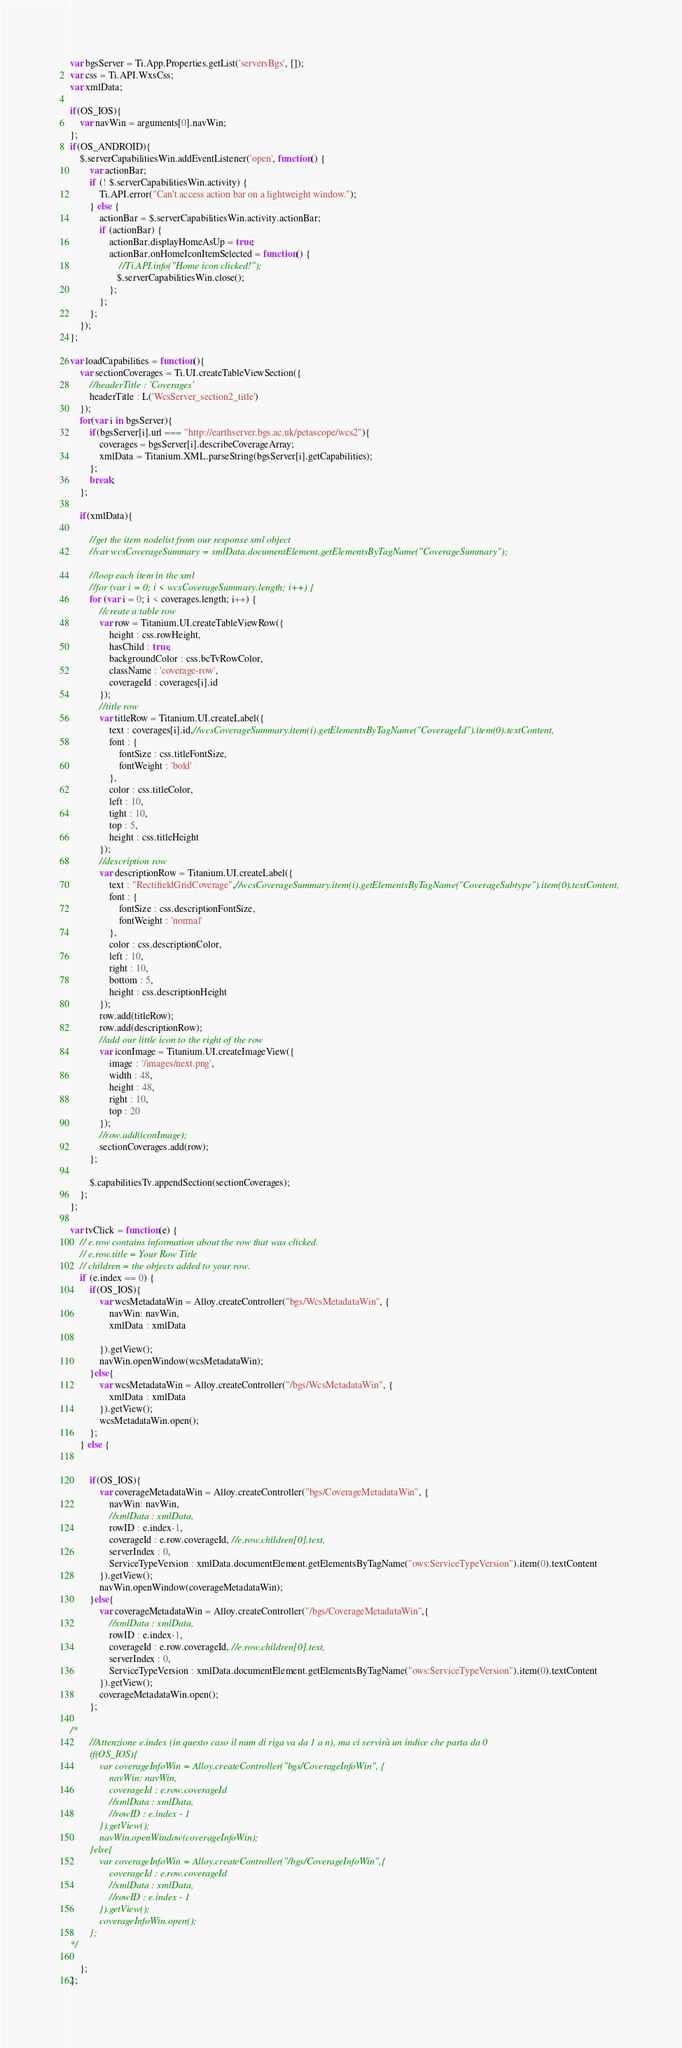Convert code to text. <code><loc_0><loc_0><loc_500><loc_500><_JavaScript_>var bgsServer = Ti.App.Properties.getList('serversBgs', []);
var css = Ti.API.WxsCss;
var xmlData;

if(OS_IOS){
	var navWin = arguments[0].navWin;
};
if(OS_ANDROID){
	$.serverCapabilitiesWin.addEventListener('open', function() {
		var actionBar;	
	    if (! $.serverCapabilitiesWin.activity) {
	        Ti.API.error("Can't access action bar on a lightweight window.");
	    } else {
	        actionBar = $.serverCapabilitiesWin.activity.actionBar;
	        if (actionBar) {
	            actionBar.displayHomeAsUp = true;
	            actionBar.onHomeIconItemSelected = function() {
	                //Ti.API.info("Home icon clicked!");
	               $.serverCapabilitiesWin.close();
	            };
	        };	        
	    };
	});	
};

var loadCapabilities = function(){
	var sectionCoverages = Ti.UI.createTableViewSection({
		//headerTitle : 'Coverages'
		headerTitle : L('WcsServer_section2_title')
	});	
	for(var i in bgsServer){
		if(bgsServer[i].url === "http://earthserver.bgs.ac.uk/petascope/wcs2"){
			coverages = bgsServer[i].describeCoverageArray;
			xmlData = Titanium.XML.parseString(bgsServer[i].getCapabilities);
		};
		break;
	};

	if(xmlData){
		
		//get the item nodelist from our response xml object
		//var wcsCoverageSummary = xmlData.documentElement.getElementsByTagName("CoverageSummary");
		
		//loop each item in the xml
		//for (var i = 0; i < wcsCoverageSummary.length; i++) {
		for (var i = 0; i < coverages.length; i++) {	
			//create a table row
			var row = Titanium.UI.createTableViewRow({
				height : css.rowHeight,
				hasChild : true,
				backgroundColor : css.bcTvRowColor,
				className : 'coverage-row',
				coverageId : coverages[i].id
			});
			//title row
			var titleRow = Titanium.UI.createLabel({
				text : coverages[i].id,//wcsCoverageSummary.item(i).getElementsByTagName("CoverageId").item(0).textContent,
				font : {
					fontSize : css.titleFontSize,
					fontWeight : 'bold'
				},
				color : css.titleColor,
				left : 10,
				tight : 10,
				top : 5,
				height : css.titleHeight
			});
			//description row
			var descriptionRow = Titanium.UI.createLabel({
				text : "RectifieldGridCoverage",//wcsCoverageSummary.item(i).getElementsByTagName("CoverageSubtype").item(0).textContent,
				font : {
					fontSize : css.descriptionFontSize,
					fontWeight : 'normal'
				},
				color : css.descriptionColor,
				left : 10,
				right : 10,
				bottom : 5,
				height : css.descriptionHeight
			});
			row.add(titleRow);
			row.add(descriptionRow);
			//add our little icon to the right of the row
			var iconImage = Titanium.UI.createImageView({
				image : '/images/next.png',
				width : 48,
				height : 48,
				right : 10,
				top : 20
			});
			//row.add(iconImage);
			sectionCoverages.add(row);
		};
		
		$.capabilitiesTv.appendSection(sectionCoverages);
	};
};

var tvClick = function(e) {
	// e.row contains information about the row that was clicked.
	// e.row.title = Your Row Title
	// children = the objects added to your row.
	if (e.index == 0) {
		if(OS_IOS){
			var wcsMetadataWin = Alloy.createController("bgs/WcsMetadataWin", {
				navWin: navWin,
				xmlData : xmlData
				
			}).getView();
			navWin.openWindow(wcsMetadataWin);
		}else{
			var wcsMetadataWin = Alloy.createController("/bgs/WcsMetadataWin", {
				xmlData : xmlData
			}).getView();
			wcsMetadataWin.open();
		};		
	} else {

	
		if(OS_IOS){
			var coverageMetadataWin = Alloy.createController("bgs/CoverageMetadataWin", {
				navWin: navWin,
				//xmlData : xmlData,
				rowID : e.index-1,
				coverageId : e.row.coverageId, //e.row.children[0].text,
				serverIndex : 0,
				ServiceTypeVersion : xmlData.documentElement.getElementsByTagName("ows:ServiceTypeVersion").item(0).textContent
			}).getView();
			navWin.openWindow(coverageMetadataWin);
		}else{
			var coverageMetadataWin = Alloy.createController("/bgs/CoverageMetadataWin",{
				//xmlData : xmlData,
				rowID : e.index-1,
				coverageId : e.row.coverageId, //e.row.children[0].text,
				serverIndex : 0,
				ServiceTypeVersion : xmlData.documentElement.getElementsByTagName("ows:ServiceTypeVersion").item(0).textContent
			}).getView();
			coverageMetadataWin.open();
		};	

/*
		//Attenzione e.index (in questo caso il num di riga va da 1 a n), ma ci servirà un indice che parta da 0
		if(OS_IOS){
			var coverageInfoWin = Alloy.createController("bgs/CoverageInfoWin", {
				navWin: navWin,
				coverageId : e.row.coverageId
				//xmlData : xmlData,
				//rowID : e.index - 1
			}).getView();
			navWin.openWindow(coverageInfoWin);
		}else{
			var coverageInfoWin = Alloy.createController("/bgs/CoverageInfoWin",{
				coverageId : e.row.coverageId
				//xmlData : xmlData,
				//rowID : e.index - 1
			}).getView();
			coverageInfoWin.open();
		};	
*/

	};
};</code> 